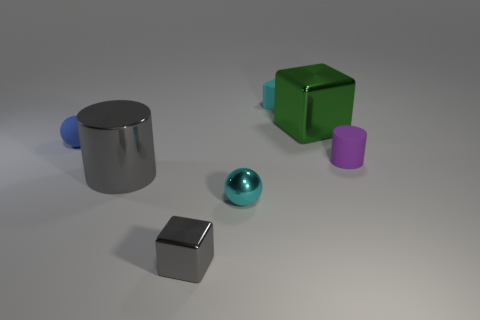Is the number of gray shiny things behind the small cyan matte block less than the number of tiny cyan matte objects that are in front of the small gray block?
Provide a short and direct response. No. What is the size of the gray object that is behind the small shiny block?
Your answer should be very brief. Large. What size is the rubber cube that is the same color as the metallic ball?
Your answer should be compact. Small. Is there a small gray cylinder that has the same material as the large green cube?
Offer a very short reply. No. Is the large green cube made of the same material as the tiny blue ball?
Offer a terse response. No. There is a cube that is the same size as the cyan matte object; what is its color?
Provide a succinct answer. Gray. What number of other objects are there of the same shape as the cyan matte thing?
Make the answer very short. 2. There is a blue rubber ball; is its size the same as the cube in front of the green cube?
Give a very brief answer. Yes. What number of things are big gray matte balls or tiny cyan metallic balls?
Make the answer very short. 1. How many other objects are the same size as the blue thing?
Provide a short and direct response. 4. 